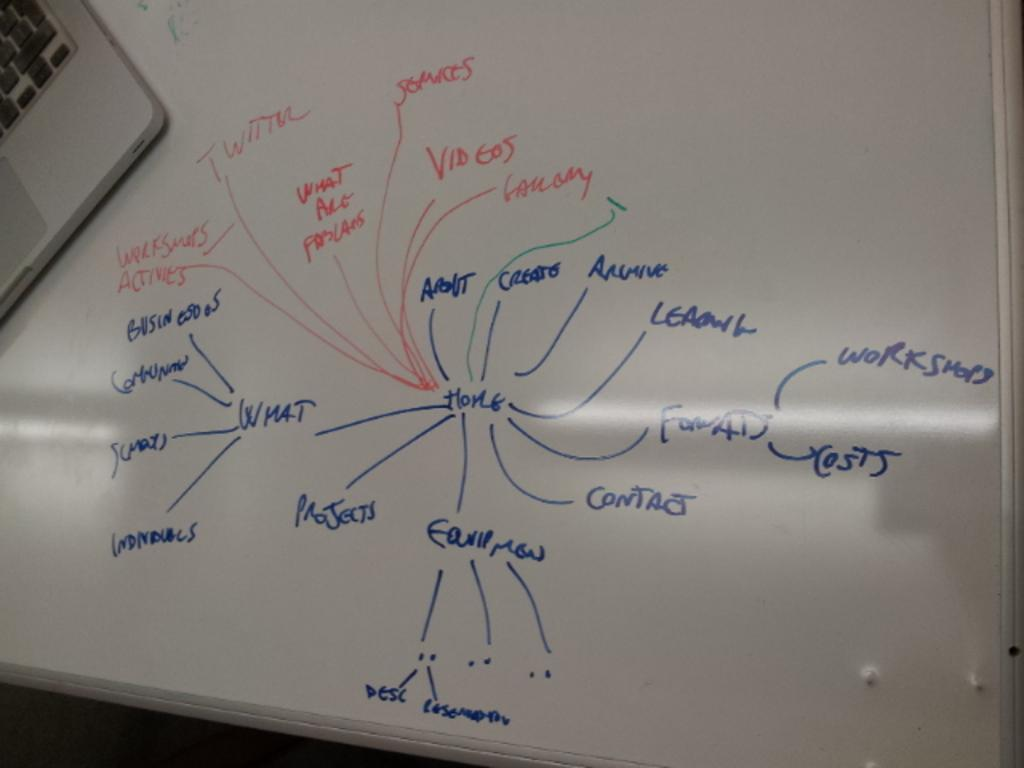<image>
Share a concise interpretation of the image provided. White board brainstorming with all words starting from "Home". 